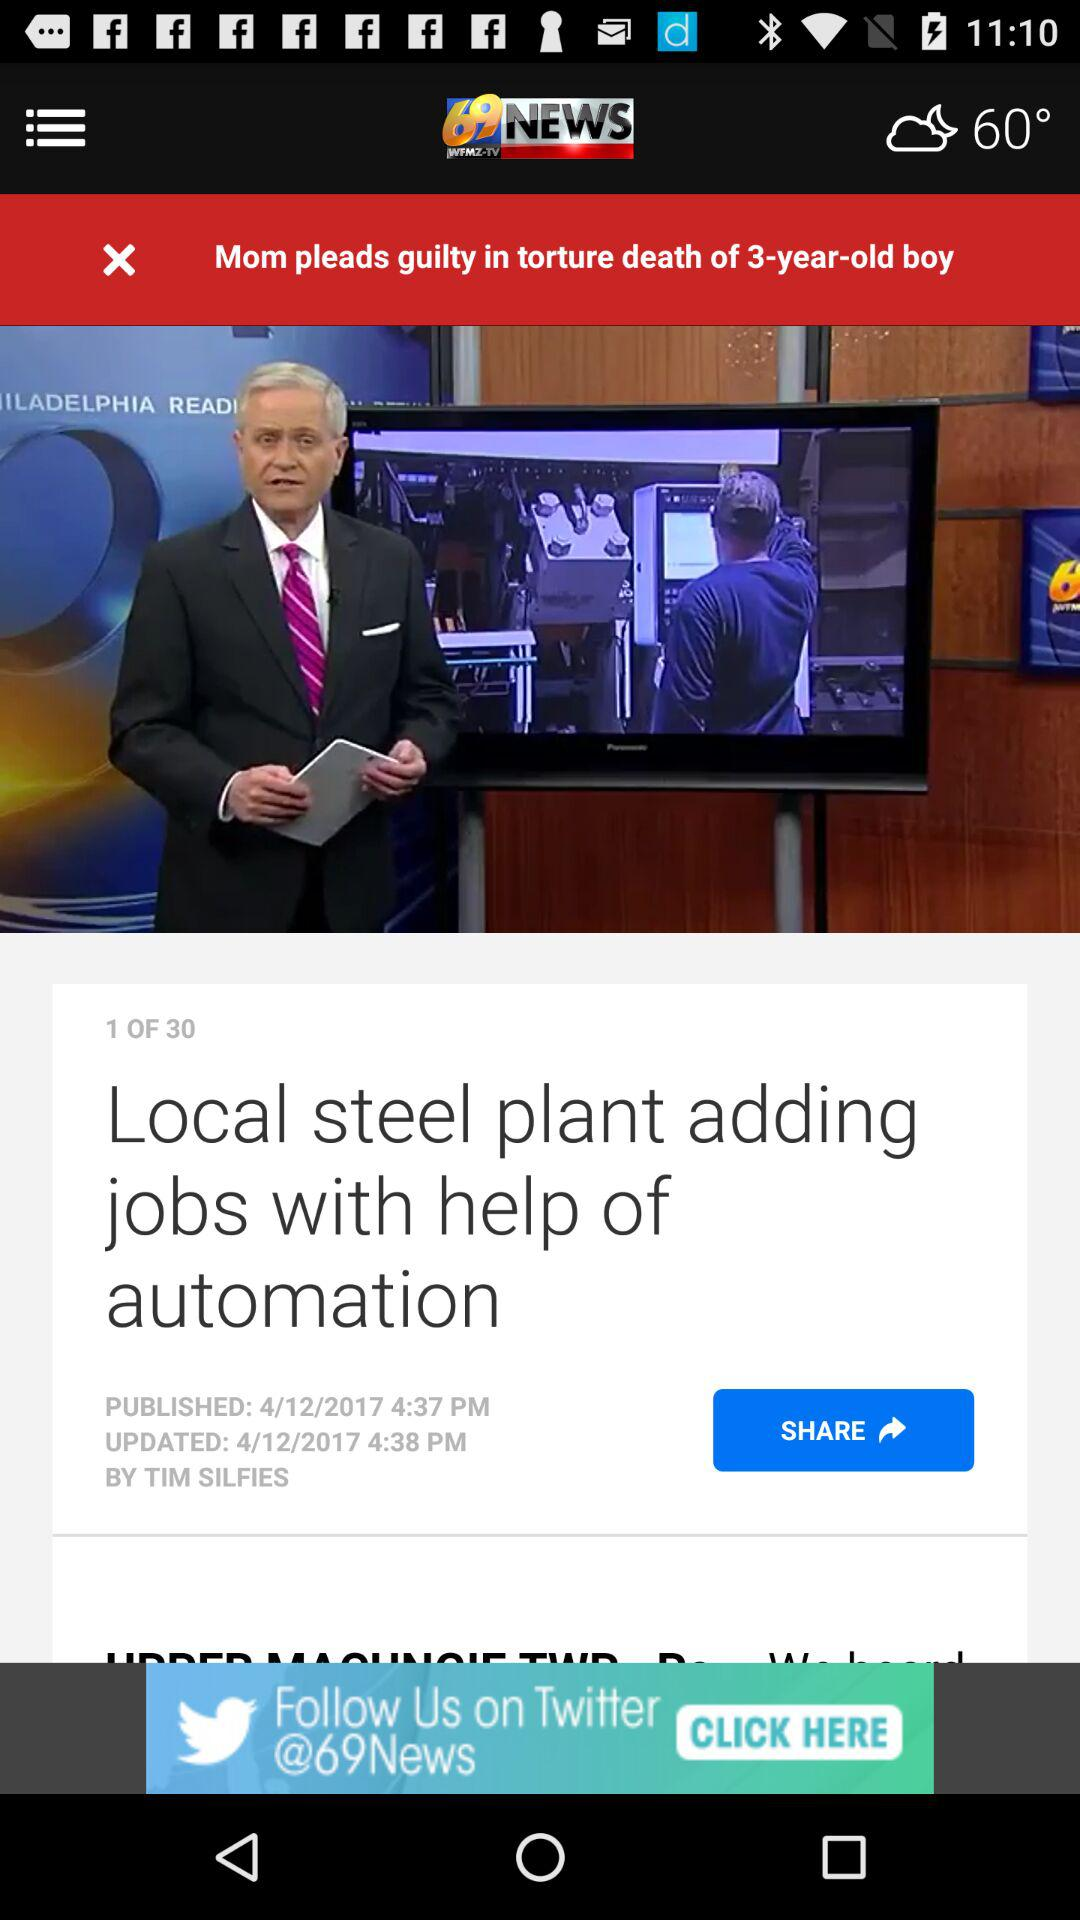What is the current news displayed? The current news displayed is "Mom pleads guilty in torture death of 3-year-old boy". 